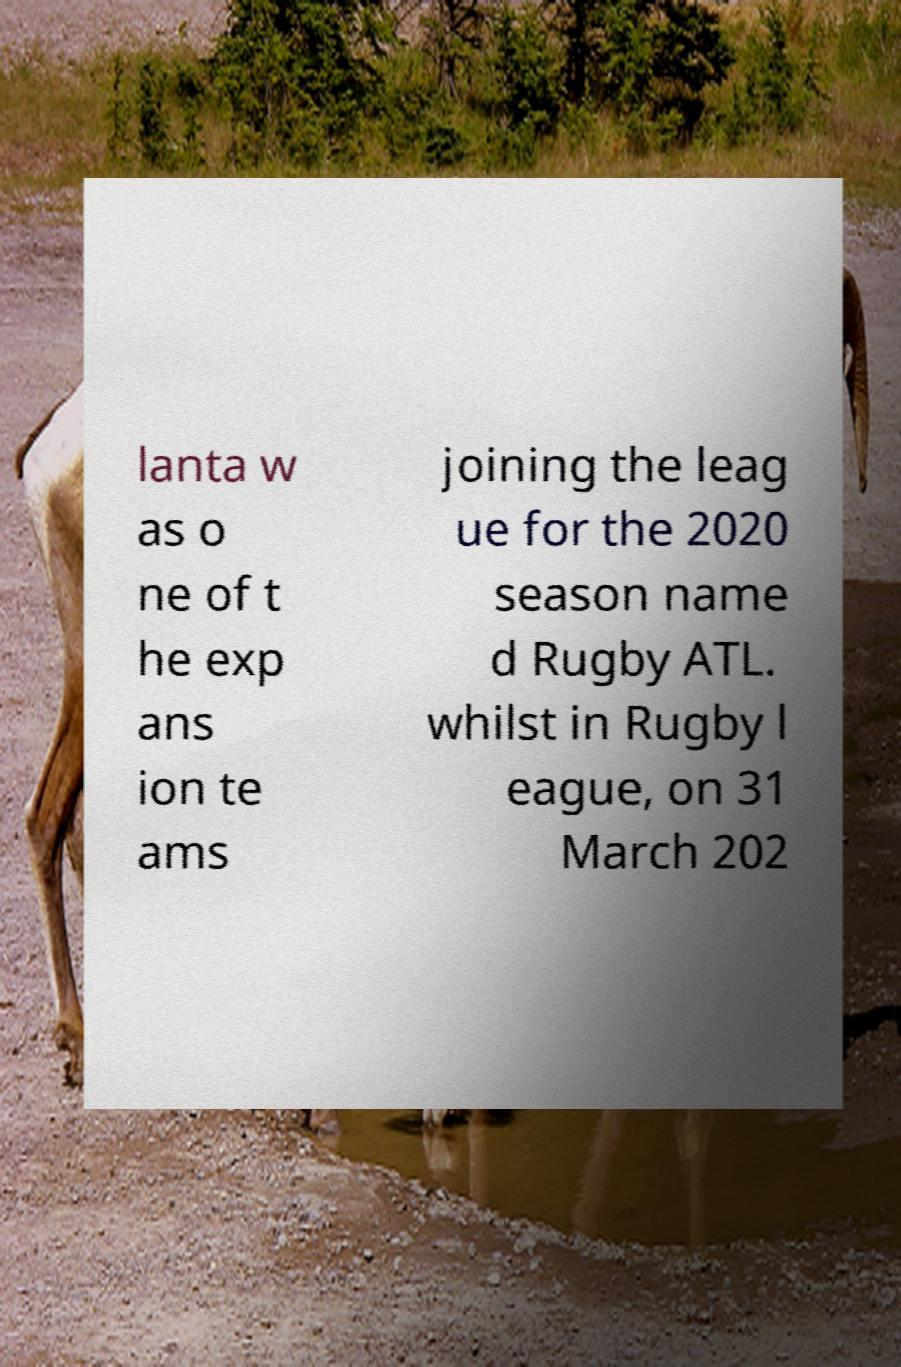I need the written content from this picture converted into text. Can you do that? lanta w as o ne of t he exp ans ion te ams joining the leag ue for the 2020 season name d Rugby ATL. whilst in Rugby l eague, on 31 March 202 